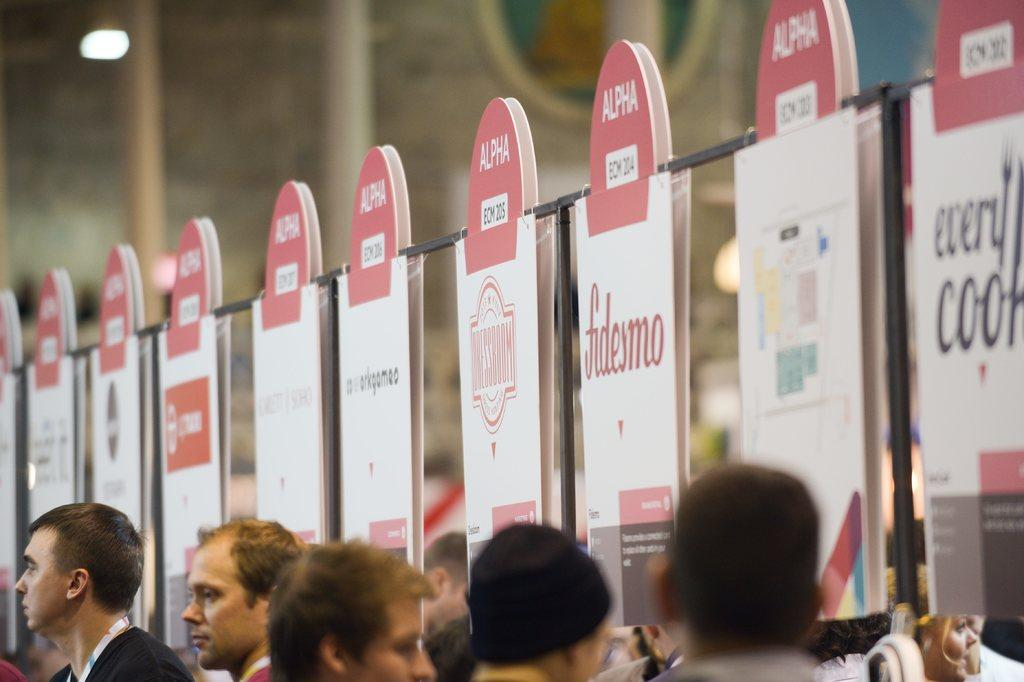What can be seen on the faces of the people in the image? The faces of the people are visible in the image. What is hanging from a rope in the image? Banners are hanging from a rope in the image. What type of pancake can be seen in the image? There is no pancake present in the image. What scent is associated with the people's faces in the image? The image does not provide any information about the scent associated with the people's faces. 